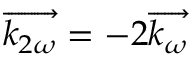<formula> <loc_0><loc_0><loc_500><loc_500>{ \overrightarrow { { k } _ { 2 \omega } } } = - 2 { \overrightarrow { { k } _ { \omega } } }</formula> 